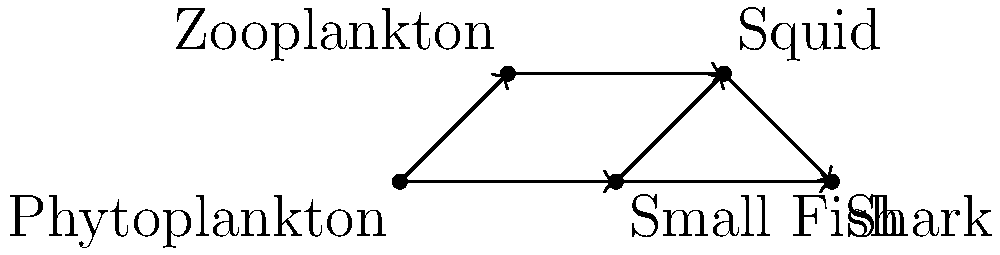In the given directed graph representing a simplified marine food web, what is the in-degree of the vertex representing "Squid", and what does this value signify in the context of the food web? To answer this question, we need to follow these steps:

1. Understand the concept of in-degree in a directed graph:
   - The in-degree of a vertex is the number of edges pointing towards that vertex.

2. Identify the vertex representing "Squid" in the graph:
   - The "Squid" vertex is the second from the top on the right side.

3. Count the number of edges pointing towards the "Squid" vertex:
   - There are two edges pointing towards the "Squid" vertex:
     a. One from "Zooplankton"
     b. One from "Small Fish"

4. Interpret the meaning of in-degree in the context of a food web:
   - In a food web, an edge pointing towards a vertex represents a predator-prey relationship.
   - The in-degree represents the number of prey species for the given organism.

5. Conclude the significance of the in-degree for "Squid":
   - An in-degree of 2 means that Squid has two prey species in this simplified food web.
   - This indicates that Squid feeds on both Zooplankton and Small Fish in this ecosystem model.
Answer: In-degree: 2; Represents the number of prey species for Squid. 